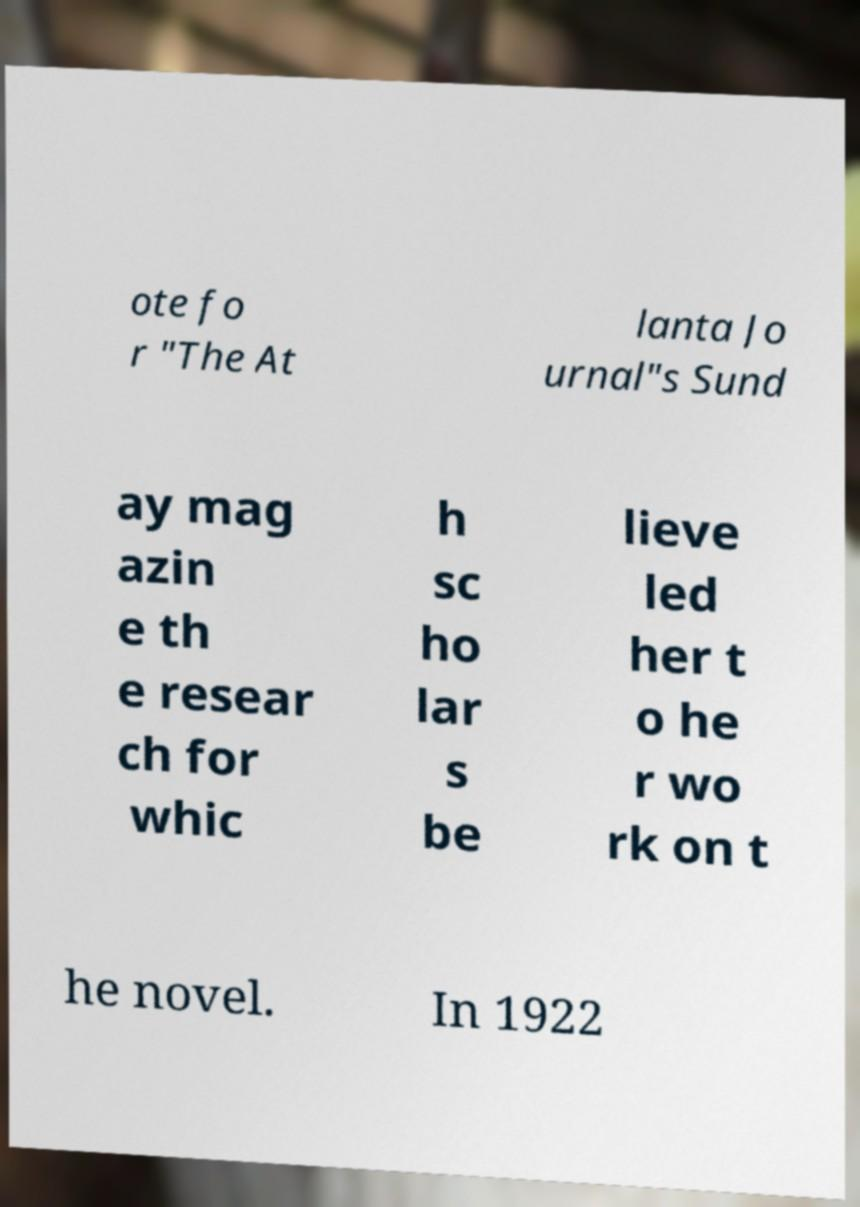What messages or text are displayed in this image? I need them in a readable, typed format. ote fo r "The At lanta Jo urnal"s Sund ay mag azin e th e resear ch for whic h sc ho lar s be lieve led her t o he r wo rk on t he novel. In 1922 